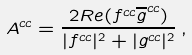<formula> <loc_0><loc_0><loc_500><loc_500>A ^ { c c } = \frac { 2 R e ( f ^ { c c } \overline { g } ^ { c c } ) } { | f ^ { c c } | ^ { 2 } + | g ^ { c c } | ^ { 2 } } \, ,</formula> 